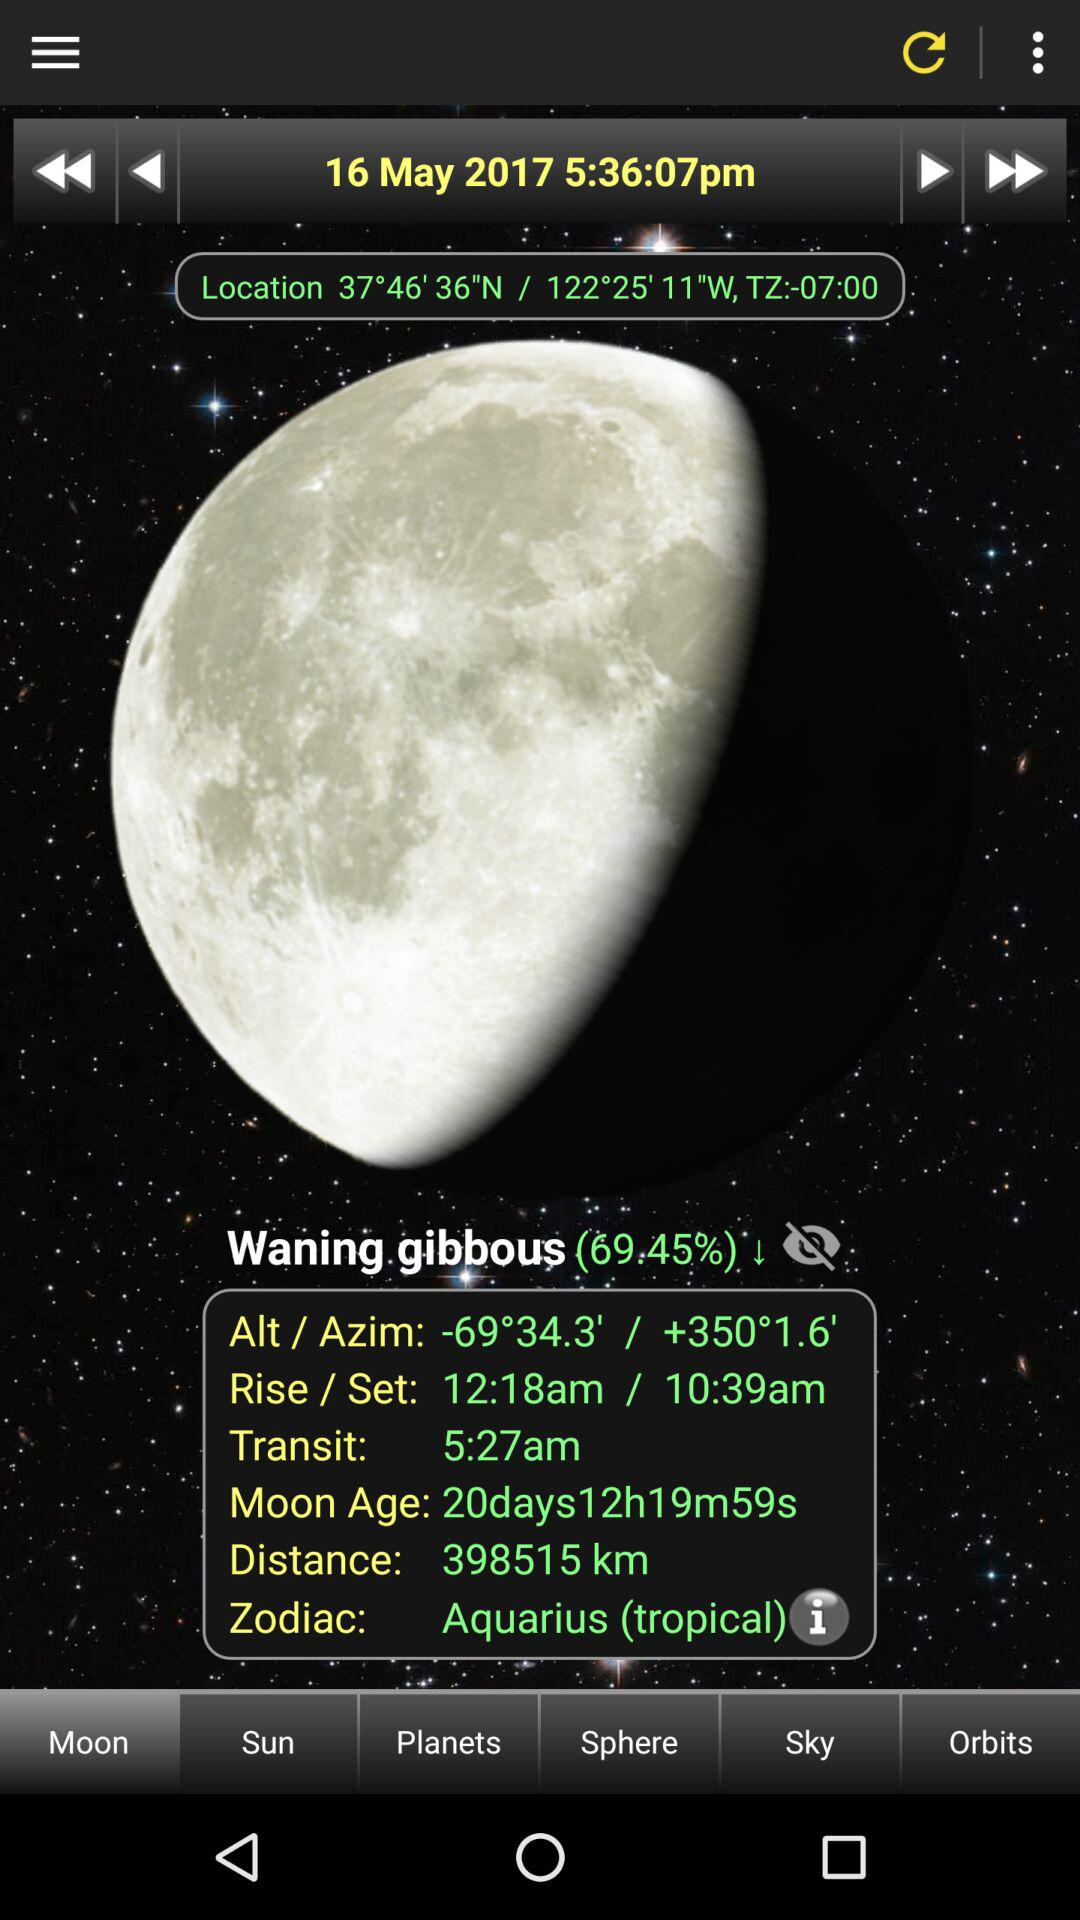What is the transit time? The transit time is 5:27 a.m. 